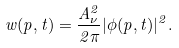<formula> <loc_0><loc_0><loc_500><loc_500>w ( p , t ) = \frac { A _ { \nu } ^ { 2 } } { 2 \pi } | \phi ( p , t ) | ^ { 2 } .</formula> 